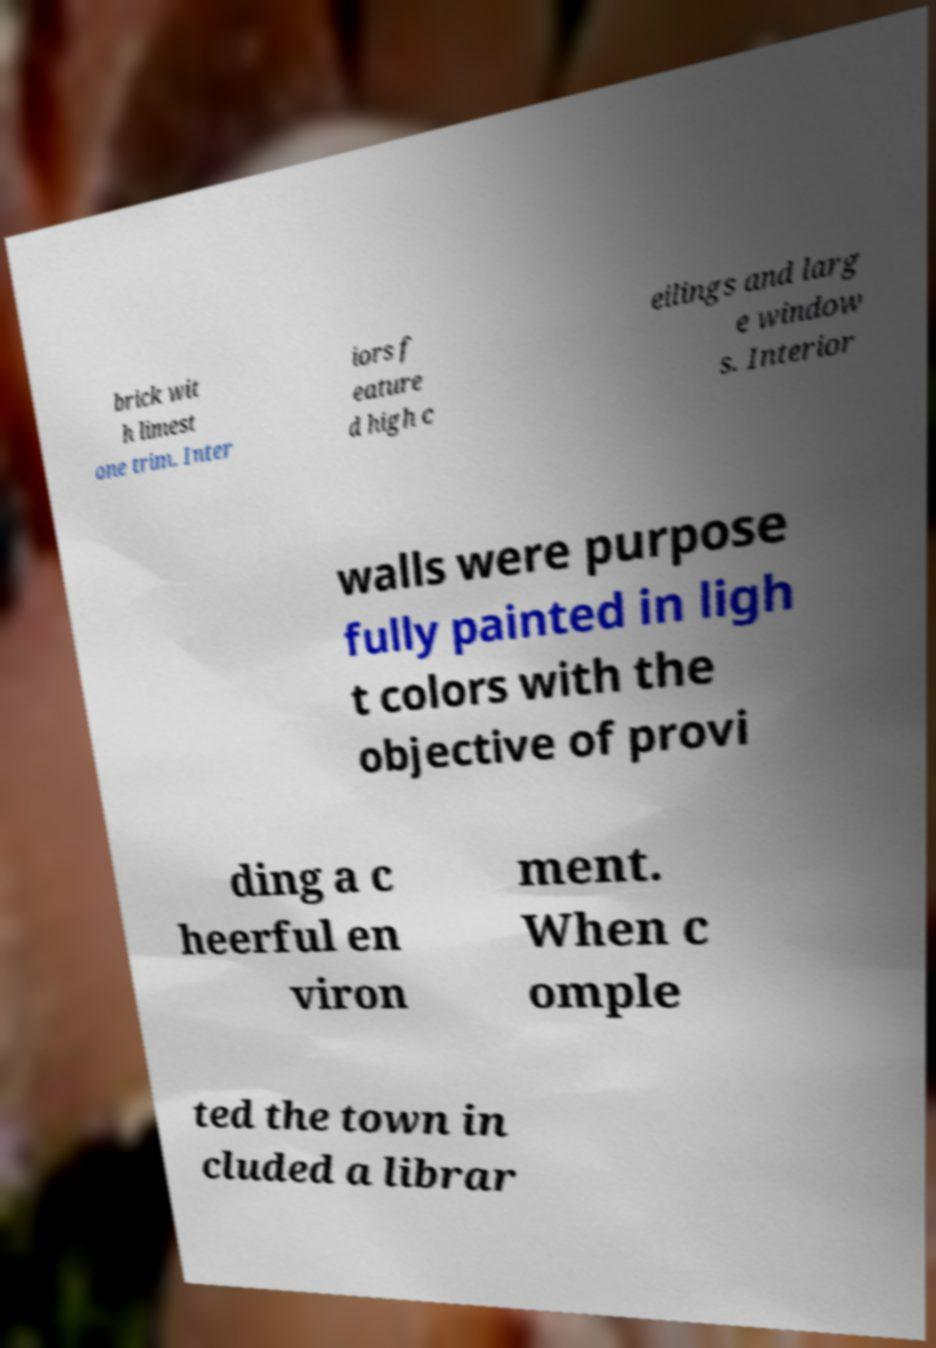Can you accurately transcribe the text from the provided image for me? brick wit h limest one trim. Inter iors f eature d high c eilings and larg e window s. Interior walls were purpose fully painted in ligh t colors with the objective of provi ding a c heerful en viron ment. When c omple ted the town in cluded a librar 